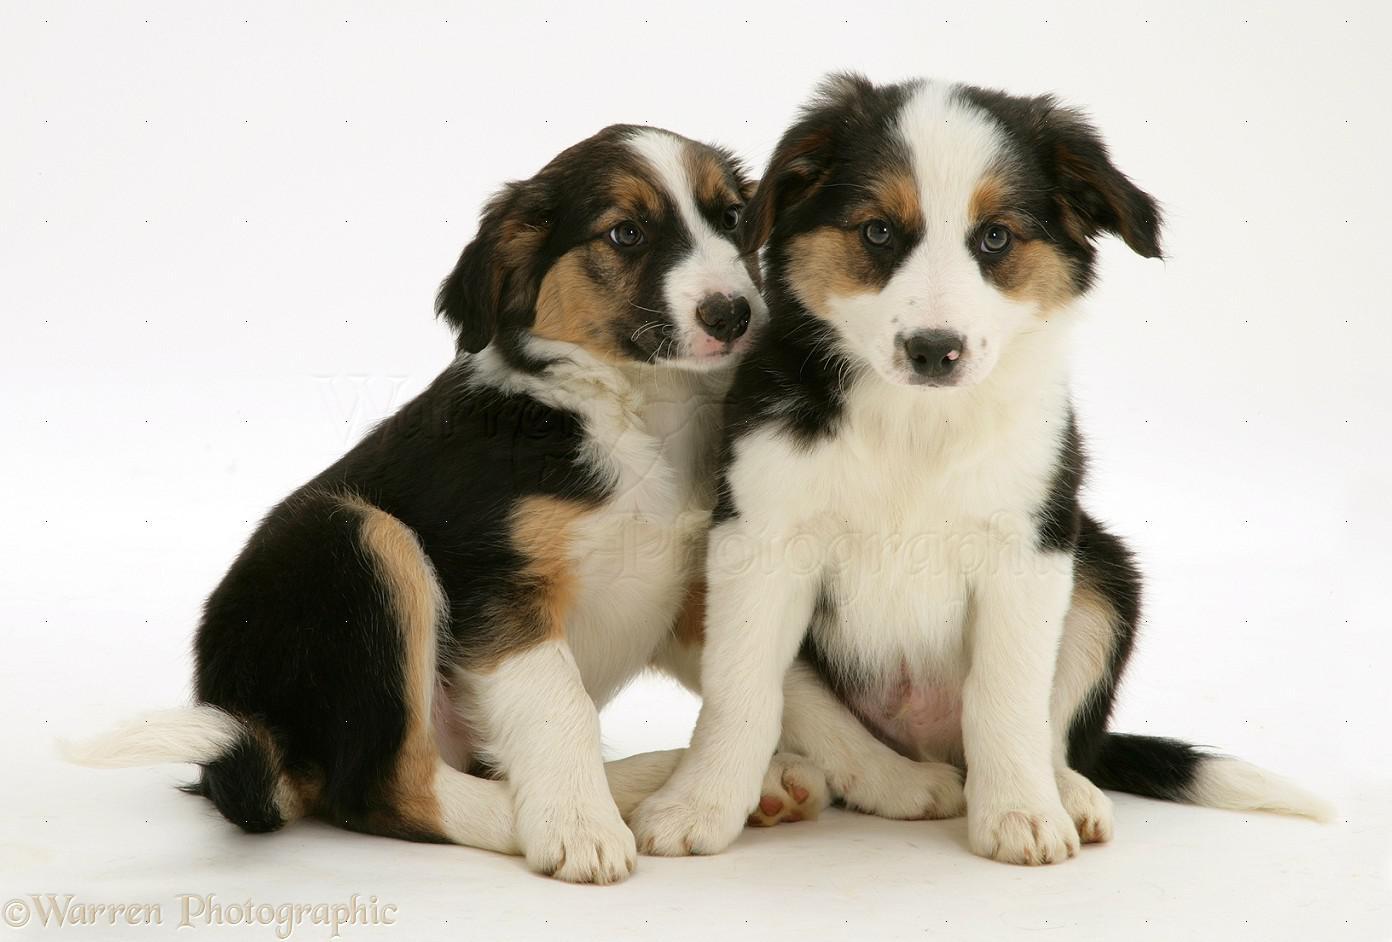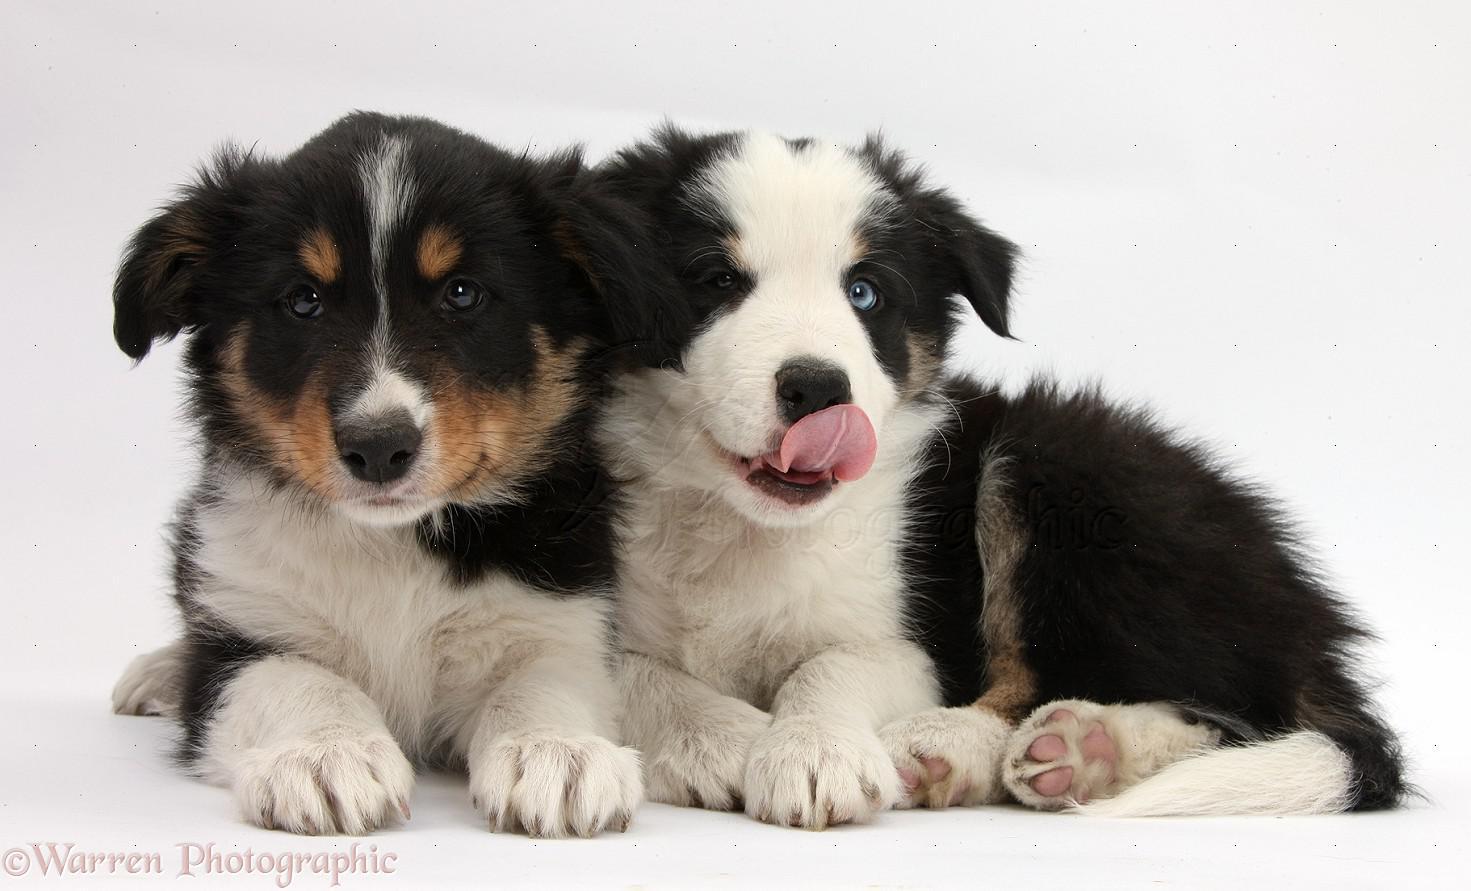The first image is the image on the left, the second image is the image on the right. Assess this claim about the two images: "Each image features exactly two animals posed close together, and one image shows two dogs in a reclining position with front paws extended.". Correct or not? Answer yes or no. Yes. The first image is the image on the left, the second image is the image on the right. Considering the images on both sides, is "The right image contains exactly two dogs." valid? Answer yes or no. Yes. 